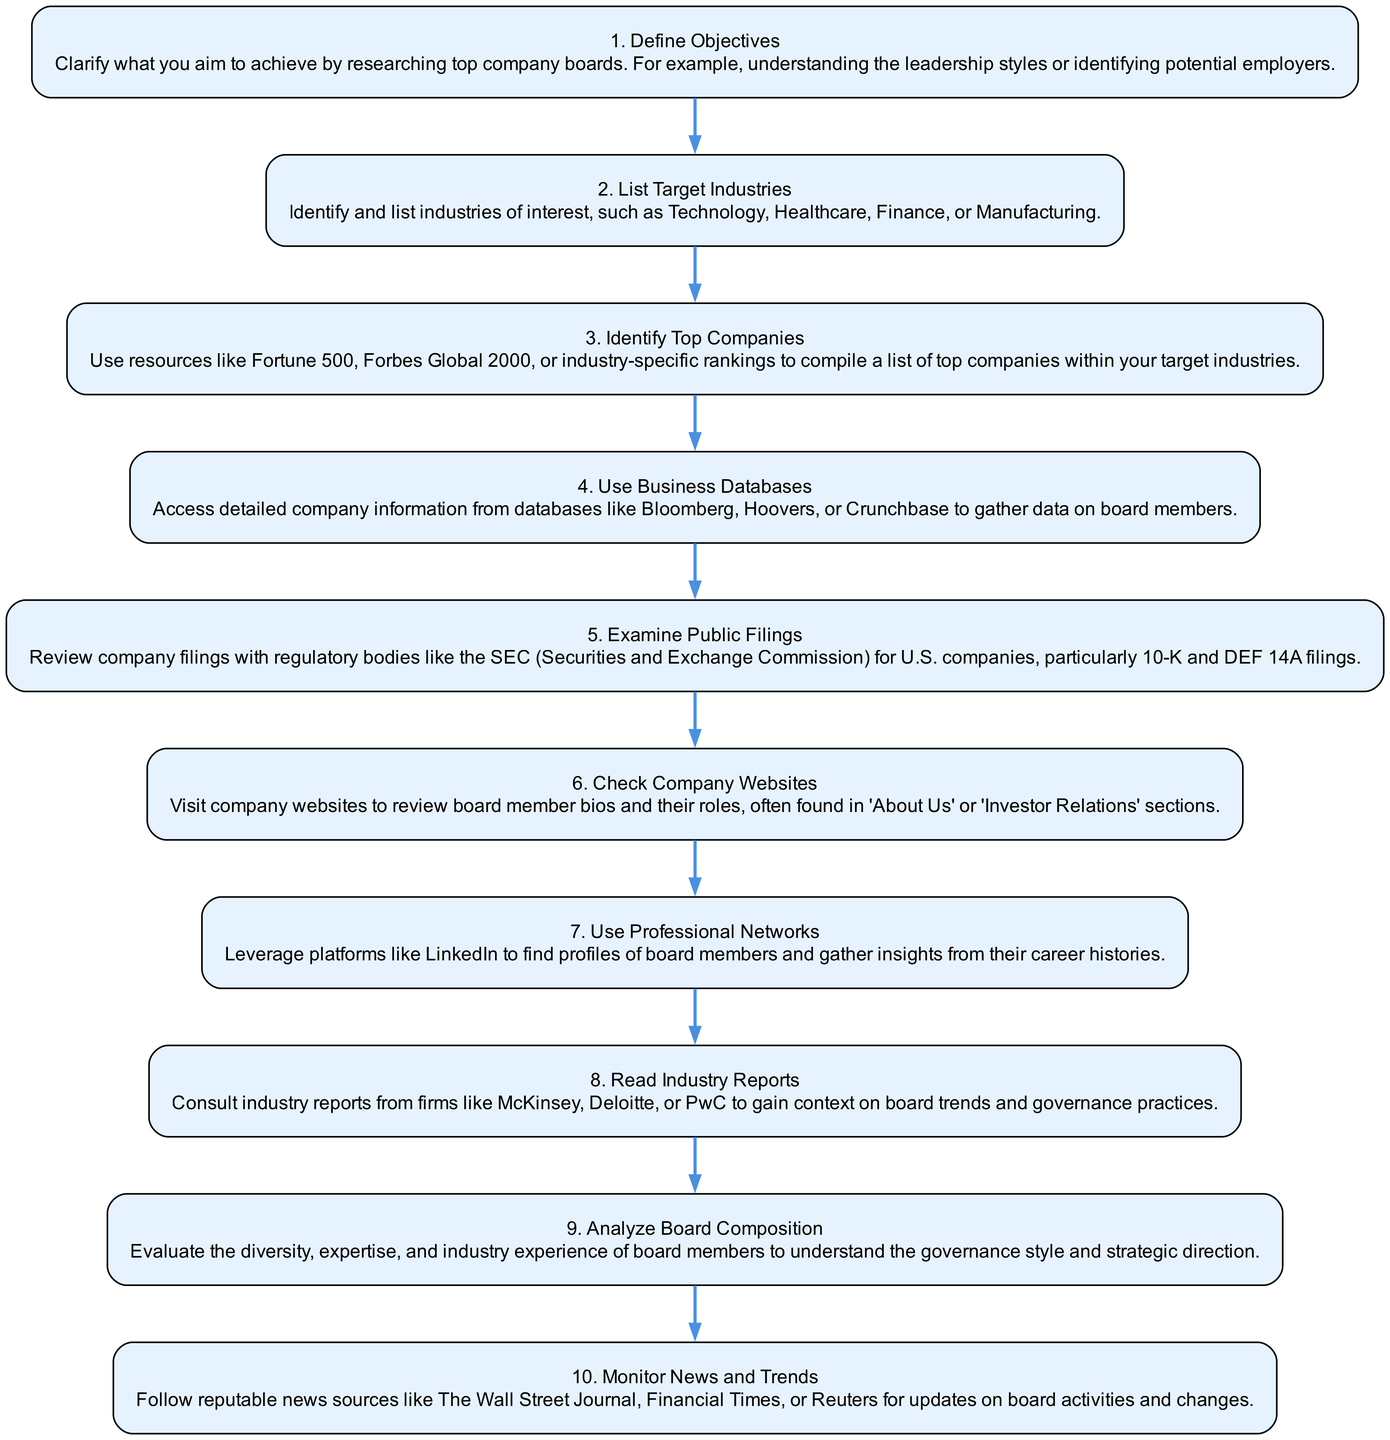What is the first step in the diagram? The first step in the diagram is labeled "Define Objectives," which is explicitly mentioned as the initial action.
Answer: Define Objectives How many total steps are listed in the diagram? By counting each individual step from the diagram, we find that there are ten steps in total.
Answer: 10 What is the last step mentioned for researching the top company boards? The last step in the flow chart is "Monitor News and Trends," indicating the final action to take.
Answer: Monitor News and Trends Which step comes after "Use Professional Networks"? The flow of the diagram shows that "Read Industry Reports" follows "Use Professional Networks," as it is connected sequentially.
Answer: Read Industry Reports What is one resource mentioned for accessing company information? The diagram specifies "Bloomberg" as one of the databases for accessing detailed company information about board members.
Answer: Bloomberg What is the relationship between "Identify Top Companies" and "Examine Public Filings"? "Examine Public Filings" is a subsequent action that follows "Identify Top Companies" in the order of steps provided in the diagram, indicating it comes after.
Answer: Subsequent action Which step emphasizes the importance of board member diversity? The "Analyze Board Composition" step specifically focuses on evaluating the diversity and expertise of board members as an important aspect.
Answer: Analyze Board Composition How many professional networks are mentioned in the steps? The diagram explicitly mentions one professional network, which is LinkedIn, as a resource to leverage for gathering insights on board members.
Answer: One What type of reports can be consulted for context on board trends? The step "Read Industry Reports" indicates consulting reports from major firms like McKinsey, which provide insights into board trends and governance practices.
Answer: Industry Reports What is the purpose of the step "Define Objectives"? This step aims to clarify the research aims, such as understanding leadership styles or identifying potential employers.
Answer: Clarify research aims 